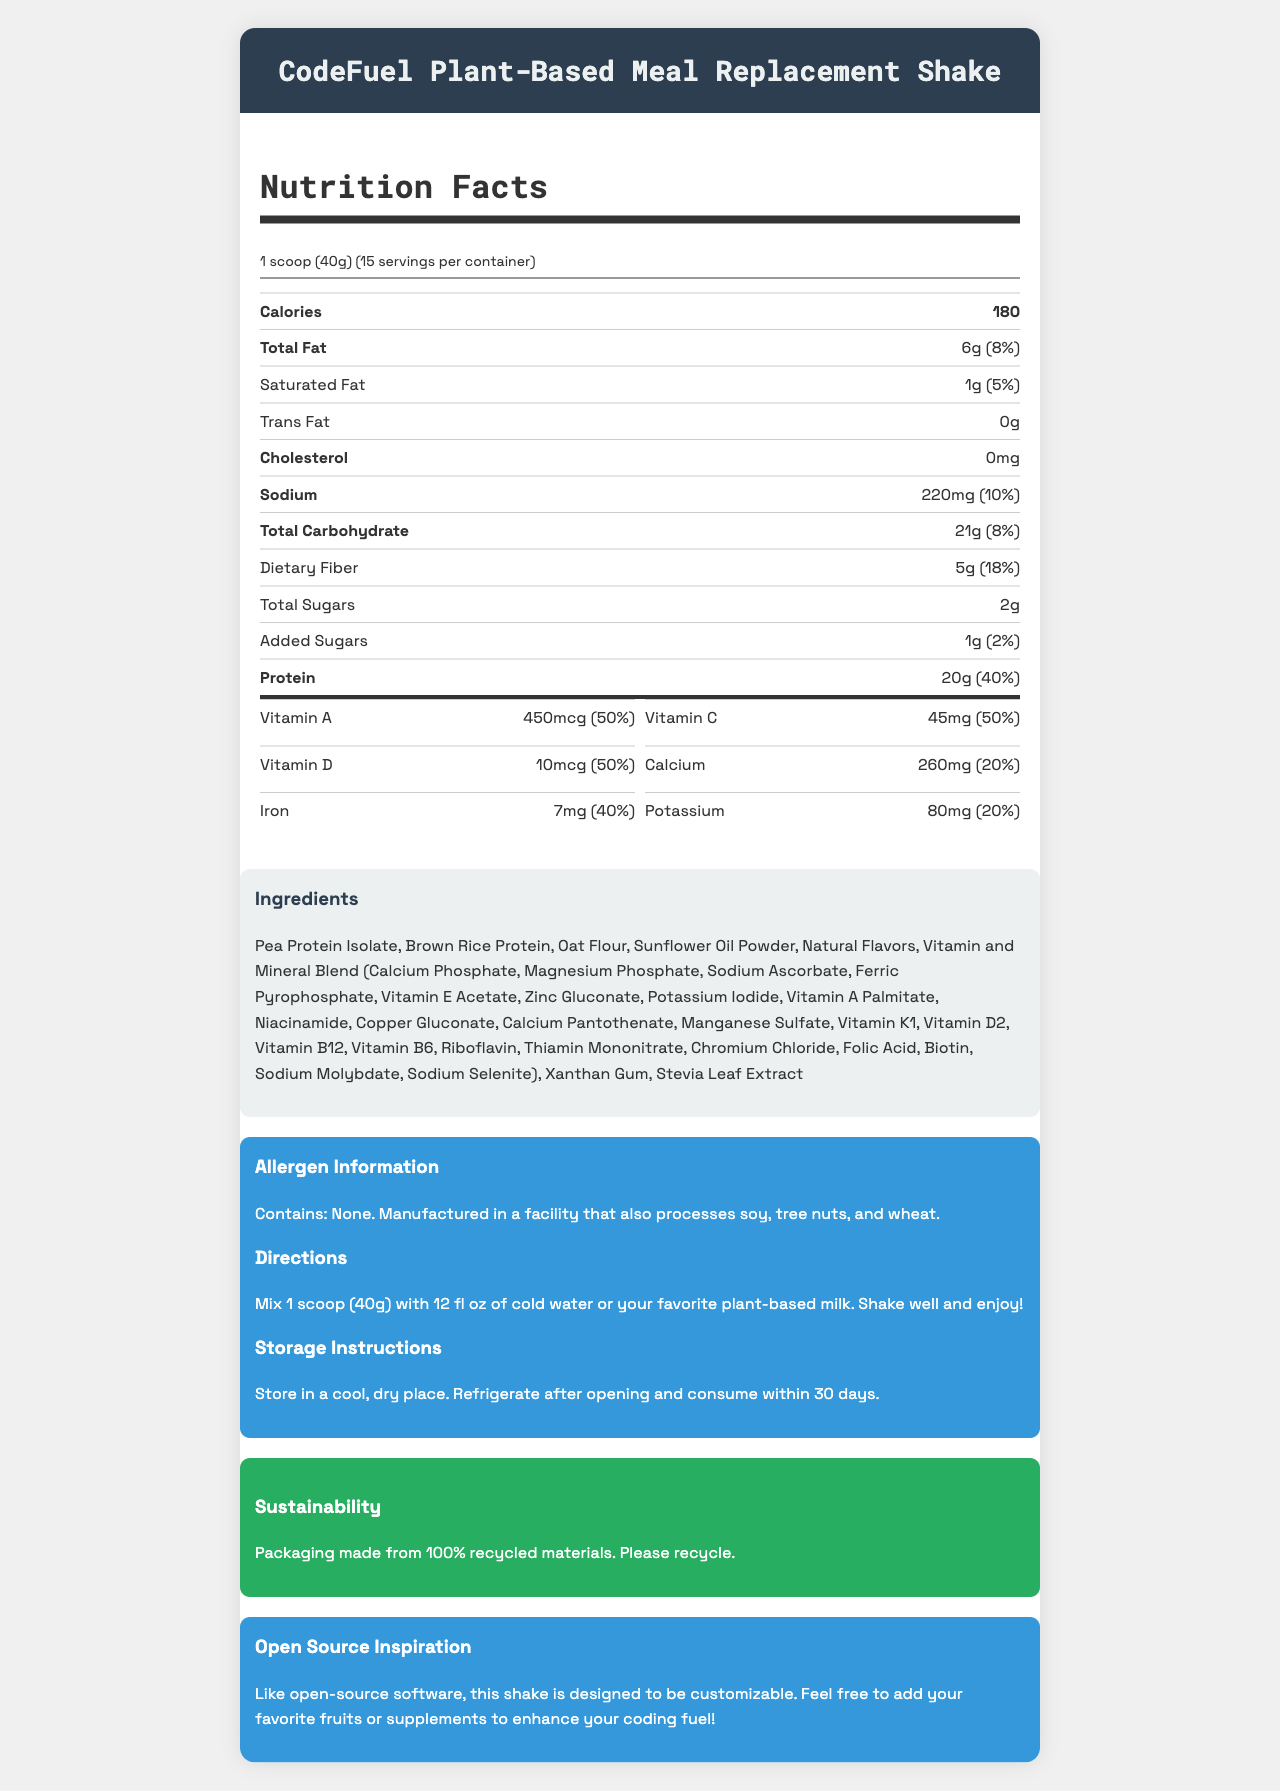what is the serving size for the CodeFuel Plant-Based Meal Replacement Shake? The serving size is explicitly mentioned as "1 scoop (40g)" in the document.
Answer: 1 scoop (40g) how many servings are in each container of the product? The document states that there are 15 servings per container.
Answer: 15 what is the total fat content per serving and its daily value percentage? The document specifies that the total fat content per serving is 6g and the daily value percentage is 8%.
Answer: 6g, 8% how much protein is in one serving of the shake, and what is its daily value percentage? The document indicates that there are 20g of protein per serving, which is 40% of the daily value.
Answer: 20g, 40% what is the amount of dietary fiber per serving and its daily value percentage? The document shows that there are 5g of dietary fiber per serving, and it comprises 18% of the daily value.
Answer: 5g, 18% how much vitamin D is included per serving and what is its daily value percentage? Each serving contains 10mcg of vitamin D, which is 50% of the daily value.
Answer: 10mcg, 50% which of the following is NOT an ingredient in the shake? A. Pea Protein Isolate B. Whey Protein C. Oat Flour D. Xanthan Gum The ingredients listed include Pea Protein Isolate, Oat Flour, and Xanthan Gum, but not Whey Protein.
Answer: B. Whey Protein how many calories are there per serving? A. 150 B. 160 C. 170 D. 180 The document specifies that there are 180 calories per serving.
Answer: D. 180 does the shake contain any trans fat? The document clearly states that the trans fat content is 0g.
Answer: No summarize the main idea of the document. The document mainly focuses on the nutritional facts and additional pertinent information about the CodeFuel Plant-Based Meal Replacement Shake.
Answer: The document provides detailed nutritional information for the CodeFuel Plant-Based Meal Replacement Shake, including serving size, calories, macronutrient and micronutrient content. It also includes ingredient information, allergen information, directions for use, storage instructions, and sustainability information. what is the total amount of sugars and added sugars per serving? The document lists 2g for total sugars and 1g for added sugars per serving.
Answer: 2g total sugars, 1g added sugars does the shake include any ingredients derived from nuts? The allergen information mentions that the product does not contain nuts; however, it is manufactured in a facility that processes soy, tree nuts, and wheat.
Answer: No list two vitamins and their daily value percentages provided in the shake. According to the document, Vitamin A and Vitamin C each have a daily value percentage of 50%.
Answer: Vitamin A: 50%, Vitamin C: 50% can the nutritional values of the shake be customized by adding fruits or supplements as per the document? The document mentions that the shake is designed to be customizable, allowing you to add fruits or supplements to enhance it.
Answer: Yes which micronutrient has a daily value percentage of 50% and is present in the smallest amount? Chromium has a daily value percentage of 50% and the smallest amount listed is 17.5mcg.
Answer: Chromium, 17.5mcg what is the suggested way to consume the shake according to the directions? The directions provided suggest mixing 1 scoop with 12 fl oz of cold water or plant-based milk, shaking it well, and then consuming.
Answer: Mix 1 scoop (40g) with 12 fl oz of cold water or your favorite plant-based milk. Shake well and enjoy! how many calories come from protein in one serving, given that protein has 4 calories per gram? Each gram of protein has 4 calories. With 20g of protein per serving, the calculation is 20g * 4 calories/g = 80 calories from protein.
Answer: 80 calories how many different vitamins and minerals are listed in the nutritional information? The document lists 21 different vitamins and minerals, including Vitamin A, C, D, E, K, and various B vitamins, calcium, iron, magnesium, zinc, selenium, copper, manganese, chromium, and molybdenum.
Answer: 21 is there any indication of the shake's compatibility with a vegan diet? The document lists ingredients typically found in vegan products and does not contain allergens related to animal products, but without explicit labeling or certification, the compatibility with a vegan diet cannot be confirmed.
Answer: Not enough information 